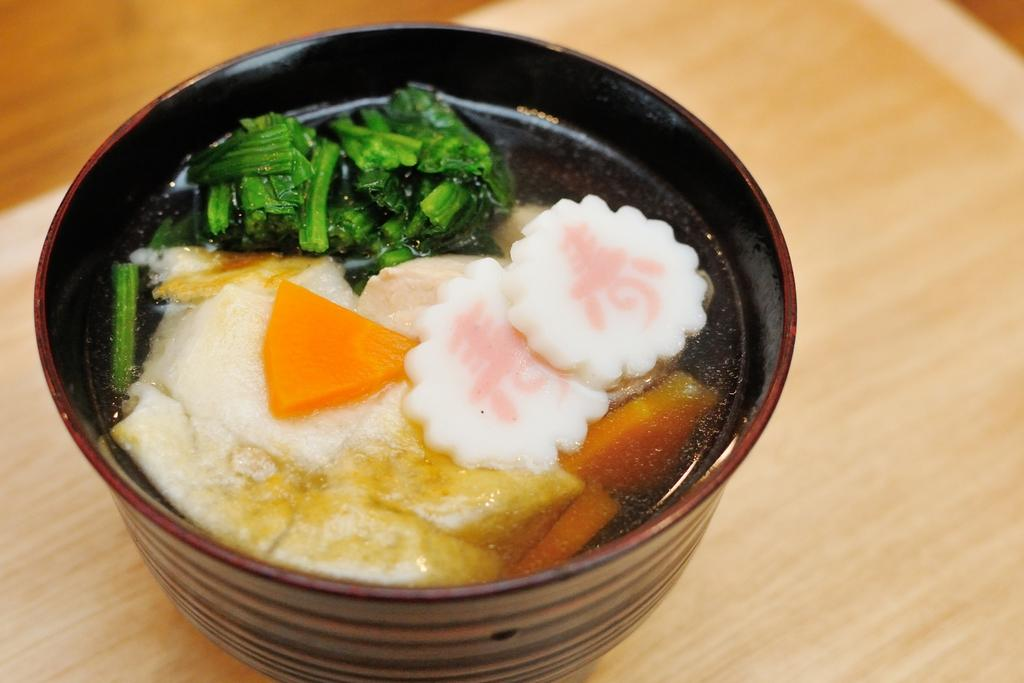What is present in the image that can hold food? There is a bowl in the image that can hold food. What type of food can be seen in the bowl? There is a food item in the bowl. What color is the background of the image? The background of the image is blue. Can you see a toad hopping in the garden in the image? There is no toad or garden present in the image; it only features a bowl with a food item against a blue background. 